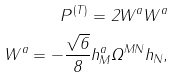<formula> <loc_0><loc_0><loc_500><loc_500>P ^ { ( T ) } = 2 W ^ { a } W ^ { a } \\ W ^ { a } = - \frac { \sqrt { 6 } } { 8 } h ^ { a } _ { M } \Omega ^ { M N } h _ { N } ,</formula> 